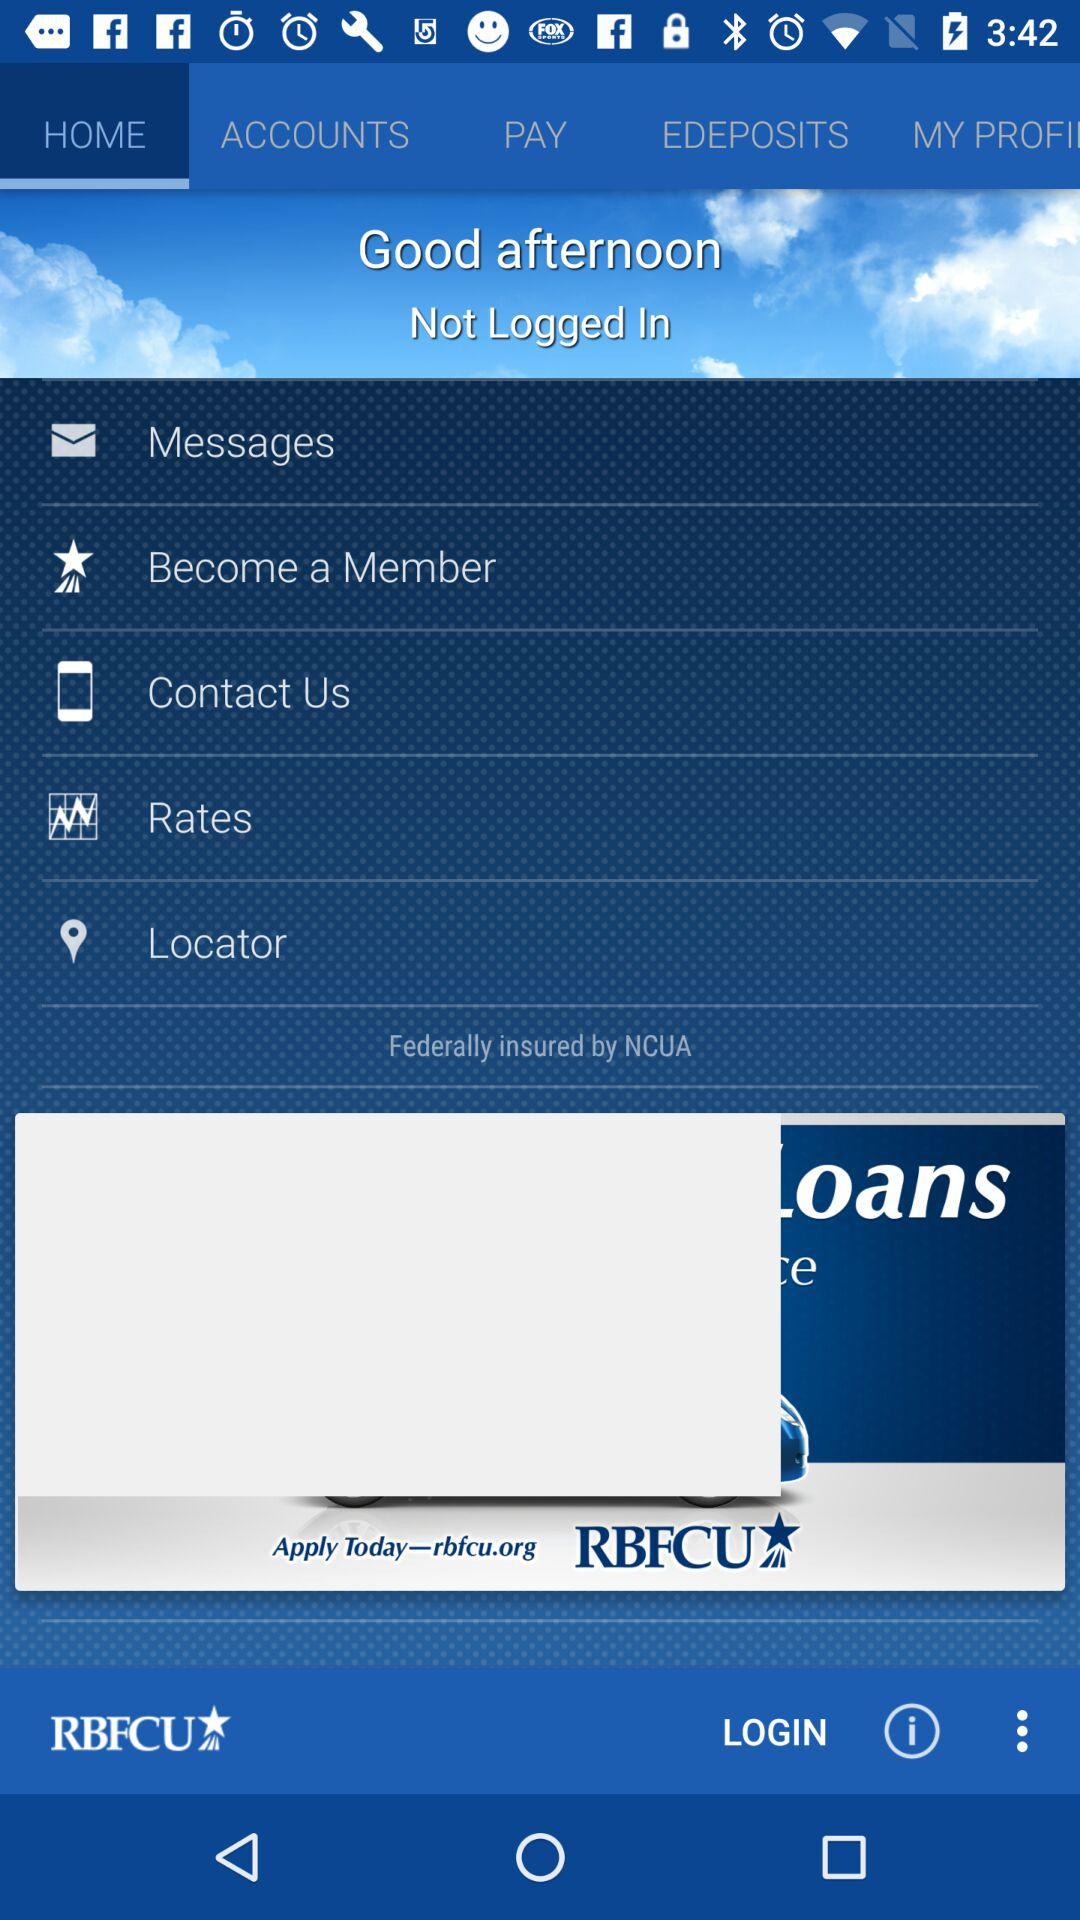What is the application name? The application name is "RBFCU". 